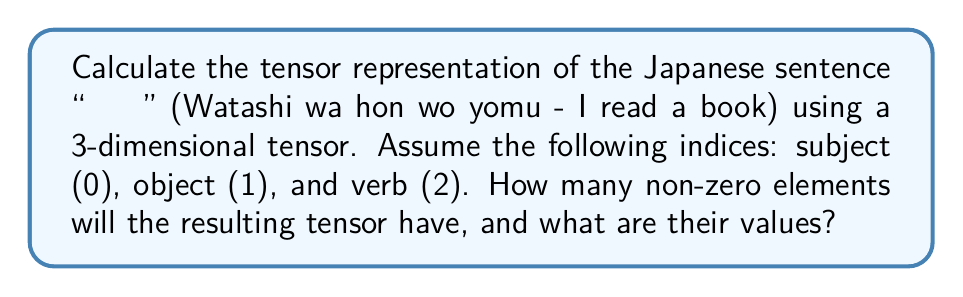What is the answer to this math problem? To represent the Japanese sentence structure using a tensor, we'll follow these steps:

1) First, we need to understand the sentence structure:
   - 私 (watashi) - subject (I)
   - 本 (hon) - object (book)
   - 読む (yomu) - verb (read)

2) We'll use a 3-dimensional tensor $T_{ijk}$ where:
   - $i$ represents the subject (index 0)
   - $j$ represents the object (index 1)
   - $k$ represents the verb (index 2)

3) In this sentence, we have one instance of each element, so we'll assign a value of 1 to each present element and 0 to absent elements.

4) The tensor will have dimensions 1x1x1 as we have one subject, one object, and one verb.

5) The non-zero element in this tensor will be:

   $$T_{012} = 1$$

   This represents the presence of a subject (0), an object (1), and a verb (2) in the sentence.

6) All other elements of the tensor will be zero:

   $$T_{ijk} = 0 \text{ for } (i,j,k) \neq (0,1,2)$$

7) Therefore, there is only one non-zero element in this tensor representation.

This tensor representation captures the basic structure of the Japanese sentence, showing the relationship between the subject, object, and verb.
Answer: 1 non-zero element: $T_{012} = 1$ 